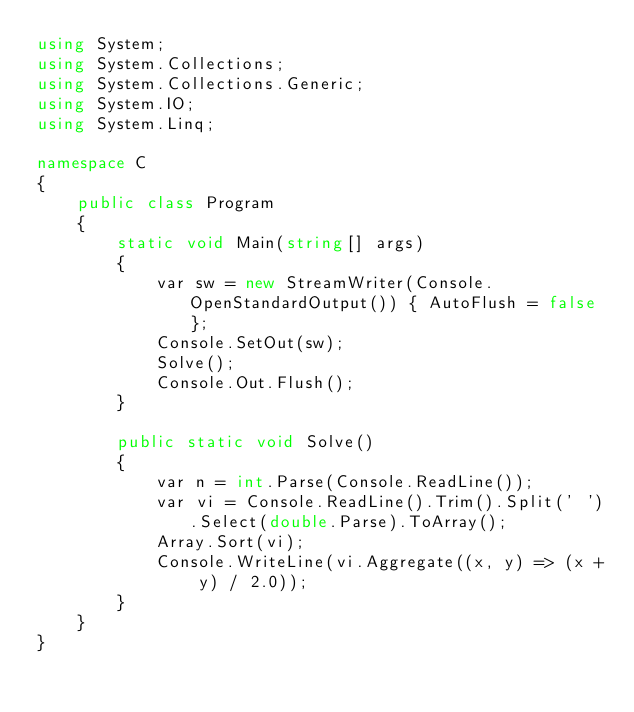<code> <loc_0><loc_0><loc_500><loc_500><_C#_>using System;
using System.Collections;
using System.Collections.Generic;
using System.IO;
using System.Linq;

namespace C
{
    public class Program
    {
        static void Main(string[] args)
        {
            var sw = new StreamWriter(Console.OpenStandardOutput()) { AutoFlush = false };
            Console.SetOut(sw);
            Solve();
            Console.Out.Flush();
        }

        public static void Solve()
        {
            var n = int.Parse(Console.ReadLine());
            var vi = Console.ReadLine().Trim().Split(' ').Select(double.Parse).ToArray();
            Array.Sort(vi);
            Console.WriteLine(vi.Aggregate((x, y) => (x + y) / 2.0));
        }
    }
}
</code> 